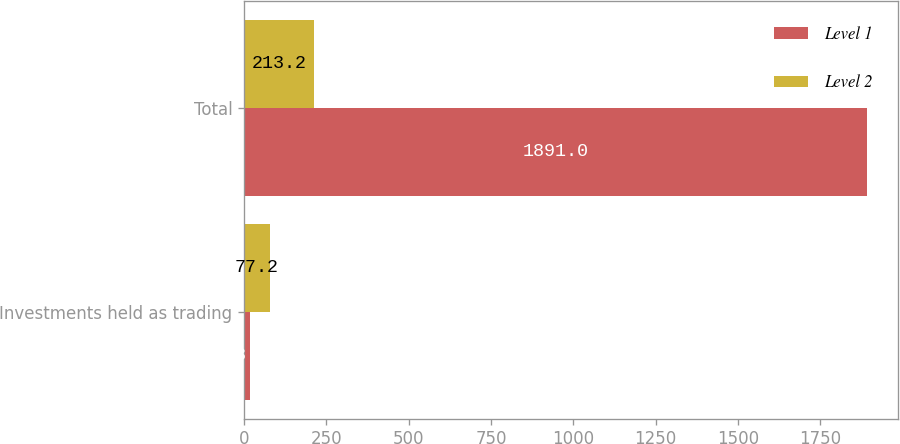Convert chart. <chart><loc_0><loc_0><loc_500><loc_500><stacked_bar_chart><ecel><fcel>Investments held as trading<fcel>Total<nl><fcel>Level 1<fcel>18.1<fcel>1891<nl><fcel>Level 2<fcel>77.2<fcel>213.2<nl></chart> 